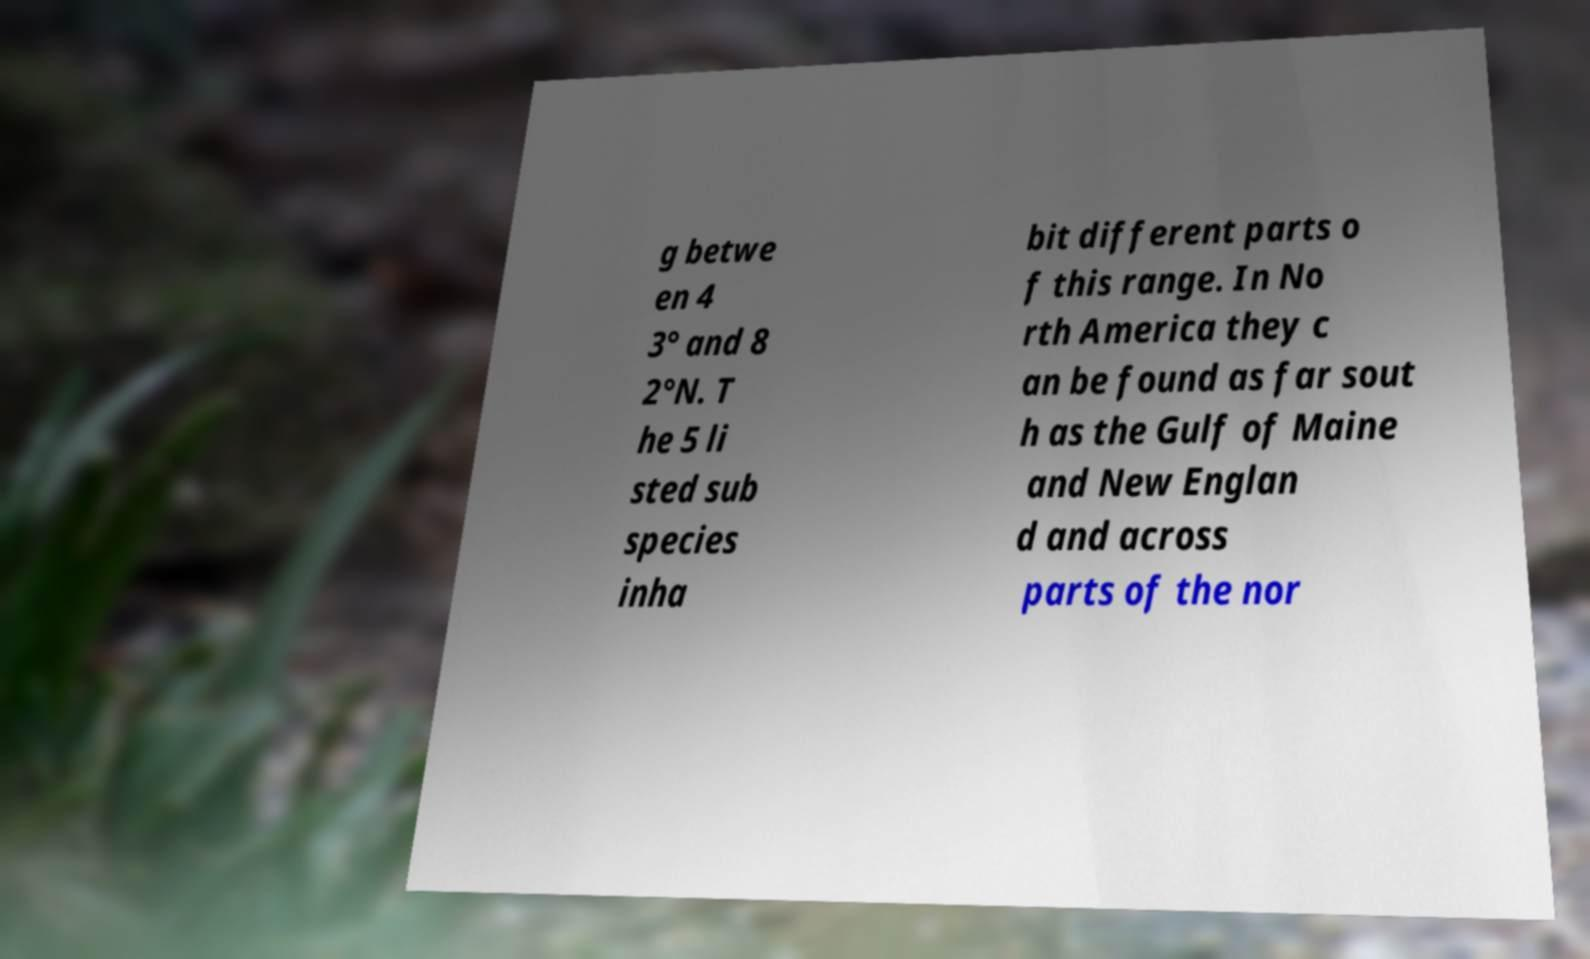What messages or text are displayed in this image? I need them in a readable, typed format. g betwe en 4 3° and 8 2°N. T he 5 li sted sub species inha bit different parts o f this range. In No rth America they c an be found as far sout h as the Gulf of Maine and New Englan d and across parts of the nor 